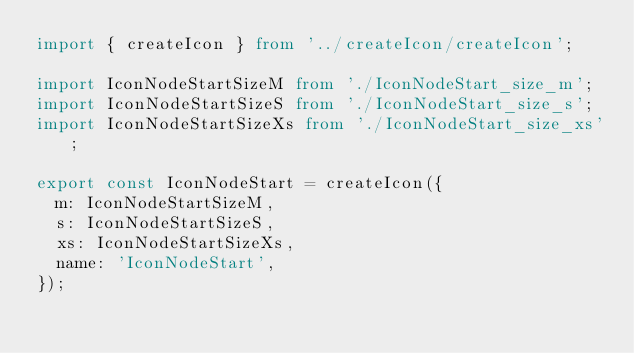<code> <loc_0><loc_0><loc_500><loc_500><_TypeScript_>import { createIcon } from '../createIcon/createIcon';

import IconNodeStartSizeM from './IconNodeStart_size_m';
import IconNodeStartSizeS from './IconNodeStart_size_s';
import IconNodeStartSizeXs from './IconNodeStart_size_xs';

export const IconNodeStart = createIcon({
  m: IconNodeStartSizeM,
  s: IconNodeStartSizeS,
  xs: IconNodeStartSizeXs,
  name: 'IconNodeStart',
});
</code> 